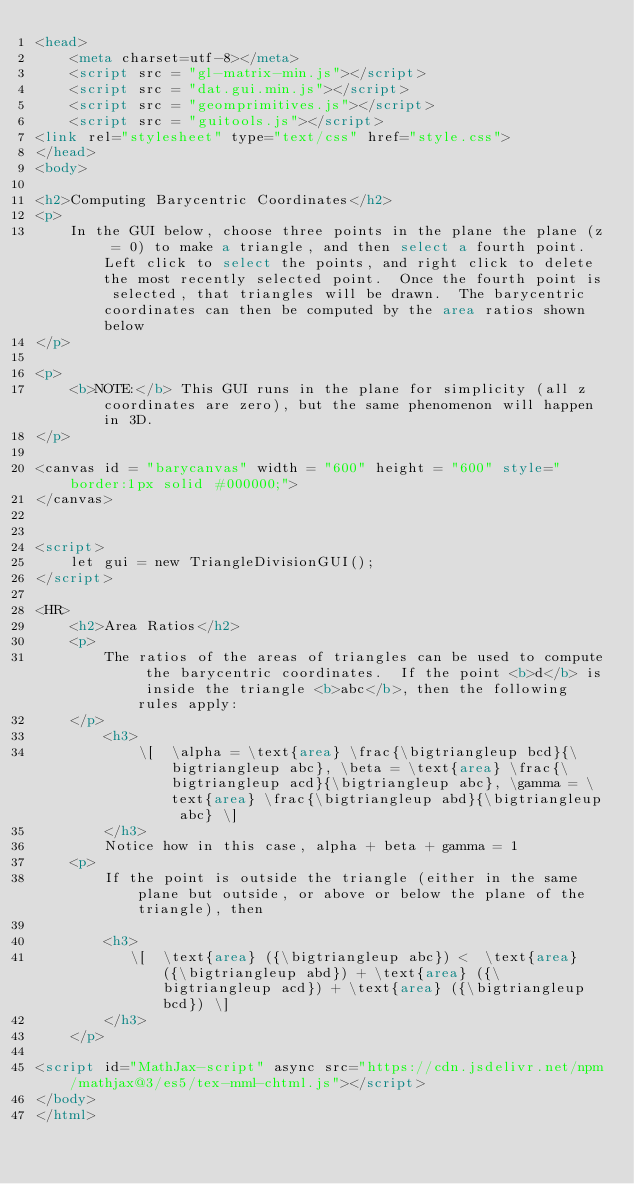<code> <loc_0><loc_0><loc_500><loc_500><_HTML_><head>
    <meta charset=utf-8></meta>
    <script src = "gl-matrix-min.js"></script>
    <script src = "dat.gui.min.js"></script>
    <script src = "geomprimitives.js"></script>
    <script src = "guitools.js"></script>
<link rel="stylesheet" type="text/css" href="style.css">
</head>
<body>

<h2>Computing Barycentric Coordinates</h2>
<p>
    In the GUI below, choose three points in the plane the plane (z = 0) to make a triangle, and then select a fourth point.  Left click to select the points, and right click to delete the most recently selected point.  Once the fourth point is selected, that triangles will be drawn.  The barycentric coordinates can then be computed by the area ratios shown below
</p>

<p>
    <b>NOTE:</b> This GUI runs in the plane for simplicity (all z coordinates are zero), but the same phenomenon will happen in 3D.
</p>

<canvas id = "barycanvas" width = "600" height = "600" style="border:1px solid #000000;">
</canvas>


<script>
    let gui = new TriangleDivisionGUI();
</script>

<HR>
    <h2>Area Ratios</h2>
    <p>
        The ratios of the areas of triangles can be used to compute the barycentric coordinates.  If the point <b>d</b> is inside the triangle <b>abc</b>, then the following rules apply:
    </p>
        <h3>
            \[  \alpha = \text{area} \frac{\bigtriangleup bcd}{\bigtriangleup abc}, \beta = \text{area} \frac{\bigtriangleup acd}{\bigtriangleup abc}, \gamma = \text{area} \frac{\bigtriangleup abd}{\bigtriangleup abc} \]
        </h3>
        Notice how in this case, alpha + beta + gamma = 1
    <p>
        If the point is outside the triangle (either in the same plane but outside, or above or below the plane of the triangle), then 

        <h3>
           \[  \text{area} ({\bigtriangleup abc}) <  \text{area} ({\bigtriangleup abd}) + \text{area} ({\bigtriangleup acd}) + \text{area} ({\bigtriangleup bcd}) \]
        </h3>
    </p>

<script id="MathJax-script" async src="https://cdn.jsdelivr.net/npm/mathjax@3/es5/tex-mml-chtml.js"></script>
</body>
</html>
</code> 